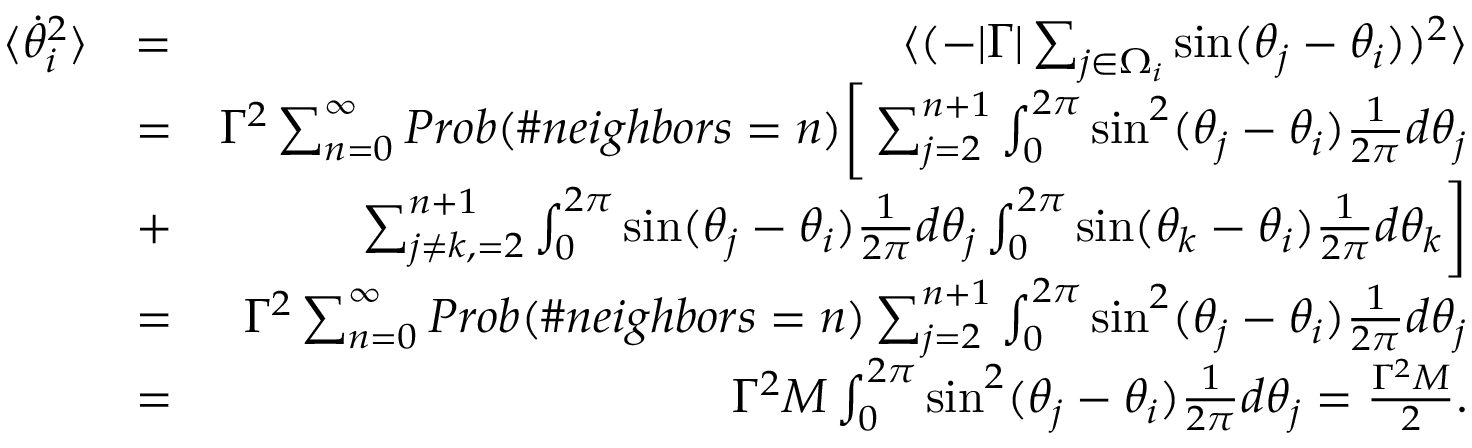<formula> <loc_0><loc_0><loc_500><loc_500>\begin{array} { r l r } { \langle \dot { \theta } _ { i } ^ { 2 } \rangle } & { = } & { \langle ( - | \Gamma | \sum _ { j \in \Omega _ { i } } \sin ( \theta _ { j } - \theta _ { i } ) ) ^ { 2 } \rangle } \\ & { = } & { \Gamma ^ { 2 } \sum _ { n = 0 } ^ { \infty } P r o b ( \# n e i g h b o r s = n ) \left [ \sum _ { j = 2 } ^ { n + 1 } \int _ { 0 } ^ { 2 \pi } \sin ^ { 2 } ( \theta _ { j } - \theta _ { i } ) \frac { 1 } { 2 \pi } d \theta _ { j } } \\ & { + } & { \sum _ { j \neq k , = 2 } ^ { n + 1 } \int _ { 0 } ^ { 2 \pi } \sin ( \theta _ { j } - \theta _ { i } ) \frac { 1 } { 2 \pi } d \theta _ { j } \int _ { 0 } ^ { 2 \pi } \sin ( \theta _ { k } - \theta _ { i } ) \frac { 1 } { 2 \pi } d \theta _ { k } \right ] } \\ & { = } & { \Gamma ^ { 2 } \sum _ { n = 0 } ^ { \infty } P r o b ( \# n e i g h b o r s = n ) \sum _ { j = 2 } ^ { n + 1 } \int _ { 0 } ^ { 2 \pi } \sin ^ { 2 } ( \theta _ { j } - \theta _ { i } ) \frac { 1 } { 2 \pi } d \theta _ { j } } \\ & { = } & { \Gamma ^ { 2 } M \int _ { 0 } ^ { 2 \pi } \sin ^ { 2 } ( \theta _ { j } - \theta _ { i } ) \frac { 1 } { 2 \pi } d \theta _ { j } = \frac { \Gamma ^ { 2 } M } { 2 } . } \end{array}</formula> 